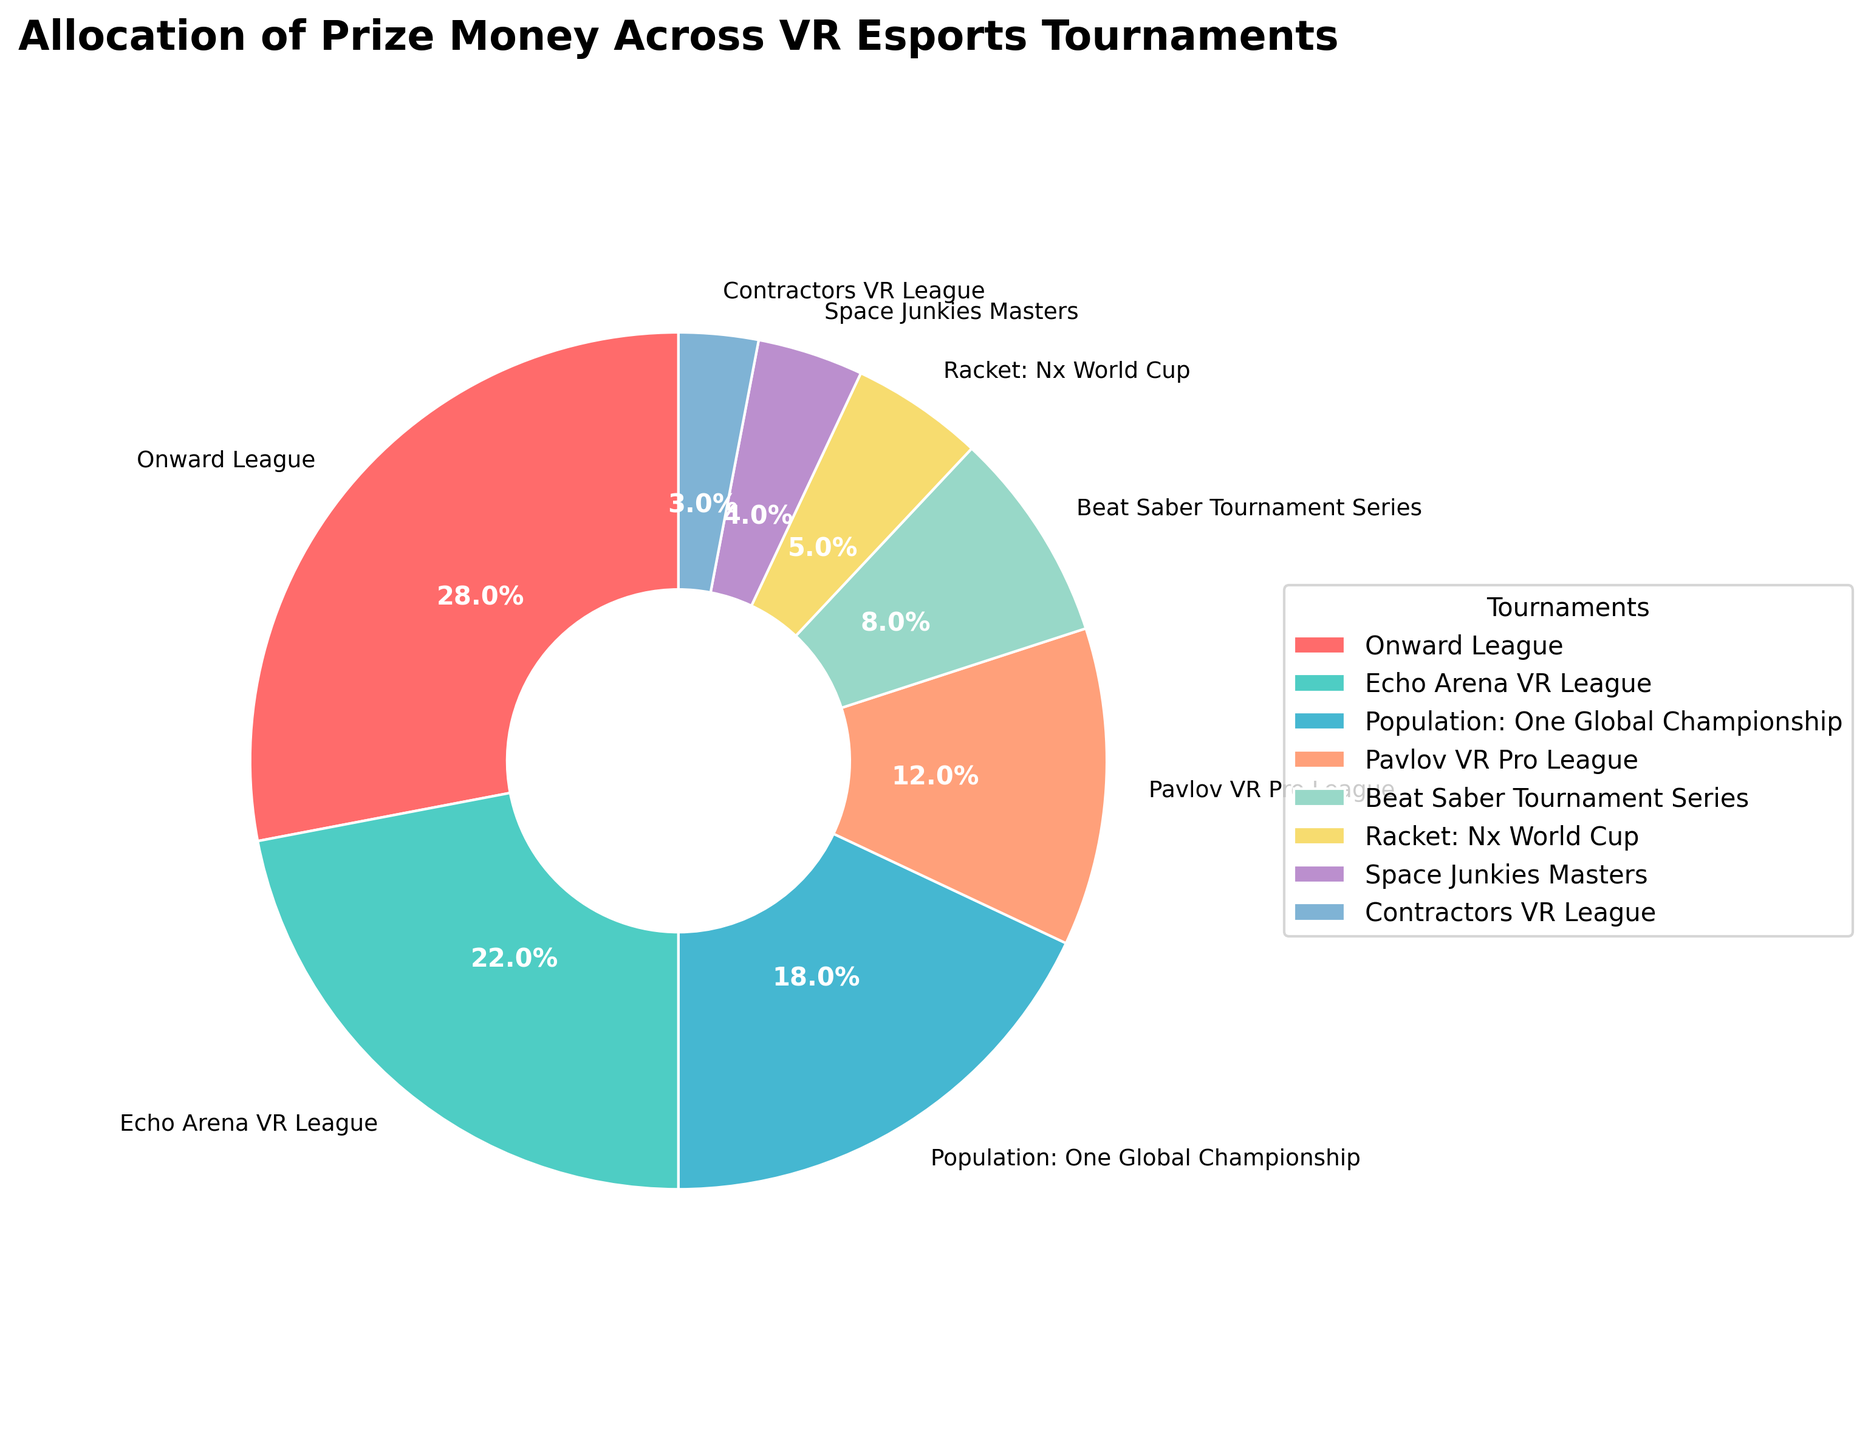What's the total prize money percentage allocated to Population: One Global Championship and Pavlov VR Pro League combined? Add the prize money percentages for Population: One Global Championship (18%) and Pavlov VR Pro League (12%). 18% + 12% = 30%
Answer: 30% Which tournament has a greater allocation of prize money: Beat Saber Tournament Series or Racket: Nx World Cup? Compare the prize money percentages of Beat Saber Tournament Series (8%) and Racket: Nx World Cup (5%). 8% is greater than 5%
Answer: Beat Saber Tournament Series What's the difference in prize money percentage between Onward League and Echo Arena VR League? Subtract the prize money percentage of Echo Arena VR League (22%) from Onward League (28%). 28% - 22% = 6%
Answer: 6% Which tournament is represented with the smallest portion of the pie chart? The tournament with the smallest prize money percentage is Contractors VR League (3%)
Answer: Contractors VR League List the tournaments allocated more than 10% of the prize money. Identify the tournaments with prize money percentages > 10%: Onward League (28%), Echo Arena VR League (22%), Population: One Global Championship (18%), Pavlov VR Pro League (12%)
Answer: Onward League, Echo Arena VR League, Population: One Global Championship, Pavlov VR Pro League What is the average prize money percentage for the three smallest tournaments? Average the percentages of Contractors VR League (3%), Space Junkies Masters (4%), and Racket: Nx World Cup (5%): (3% + 4% + 5%) / 3 = 12% / 3 = 4%
Answer: 4% What color represents the Pavlov VR Pro League in the pie chart? Observe the color assigned to Pavlov VR Pro League, which is fourth on the list of colors. The fourth color is light orange
Answer: light orange (peach) How much more prize money is allocated to the Onward League compared to Population: One Global Championship? Subtract Population: One Global Championship's prize money percentage (18%) from Onward League (28%). 28% - 18% = 10%
Answer: 10% What is the total prize money percentage for the tournaments designated with more than one shade of blue or green? Sum the percentages for Echo Arena VR League (22%), Racket: Nx World Cup (5%), and Contractors VR League (3%): 22% + 5% + 3% = 30%
Answer: 30% By looking at the central portion of the pie chart, which tournament has the largest segment and what is its percentage? The largest segment in the central portion represents the Onward League, which has the largest prize money percentage of 28%
Answer: Onward League, 28% 